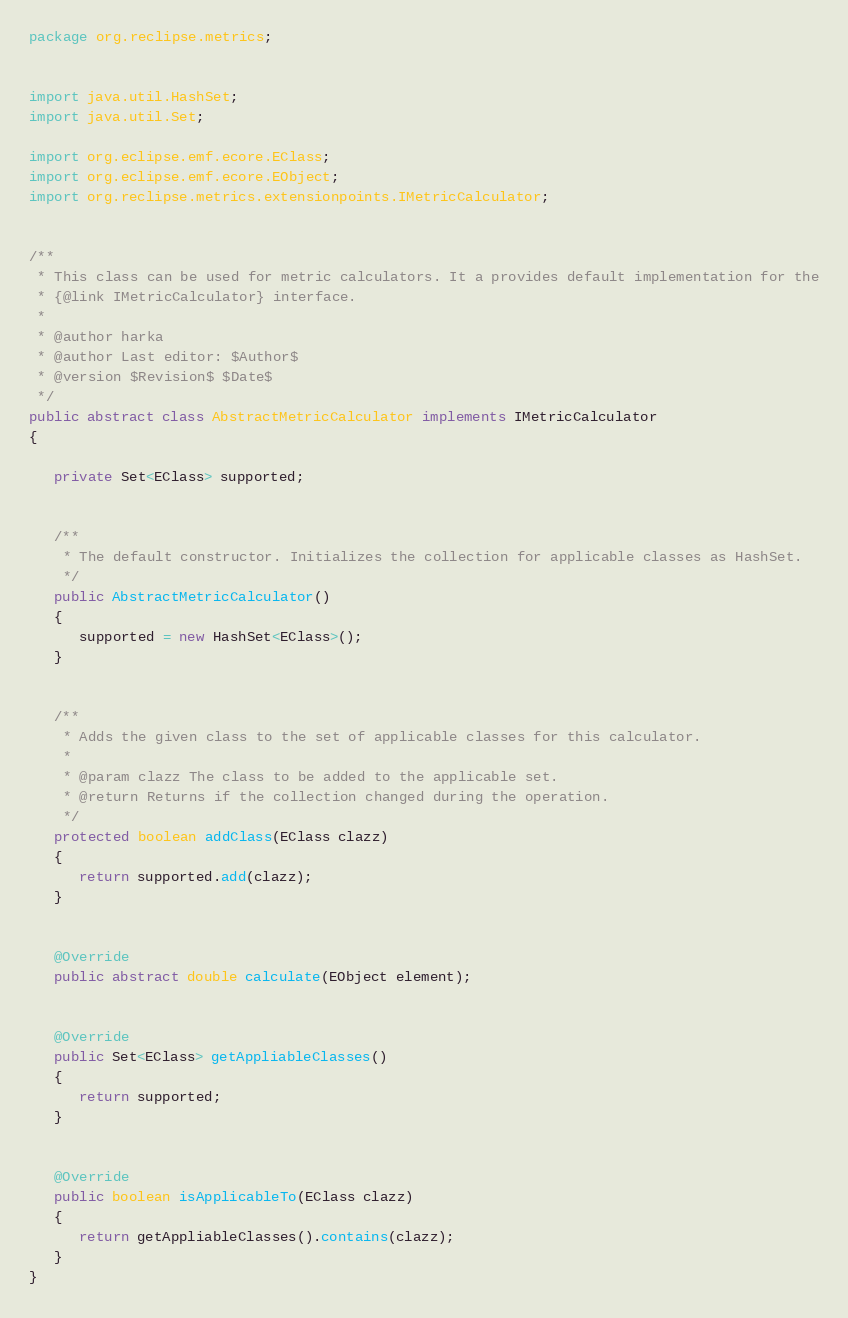<code> <loc_0><loc_0><loc_500><loc_500><_Java_>package org.reclipse.metrics;


import java.util.HashSet;
import java.util.Set;

import org.eclipse.emf.ecore.EClass;
import org.eclipse.emf.ecore.EObject;
import org.reclipse.metrics.extensionpoints.IMetricCalculator;


/**
 * This class can be used for metric calculators. It a provides default implementation for the
 * {@link IMetricCalculator} interface.
 * 
 * @author harka
 * @author Last editor: $Author$
 * @version $Revision$ $Date$
 */
public abstract class AbstractMetricCalculator implements IMetricCalculator
{

   private Set<EClass> supported;


   /**
    * The default constructor. Initializes the collection for applicable classes as HashSet.
    */
   public AbstractMetricCalculator()
   {
      supported = new HashSet<EClass>();
   }


   /**
    * Adds the given class to the set of applicable classes for this calculator.
    * 
    * @param clazz The class to be added to the applicable set.
    * @return Returns if the collection changed during the operation.
    */
   protected boolean addClass(EClass clazz)
   {
      return supported.add(clazz);
   }


   @Override
   public abstract double calculate(EObject element);


   @Override
   public Set<EClass> getAppliableClasses()
   {
      return supported;
   }


   @Override
   public boolean isApplicableTo(EClass clazz)
   {
      return getAppliableClasses().contains(clazz);
   }
}
</code> 